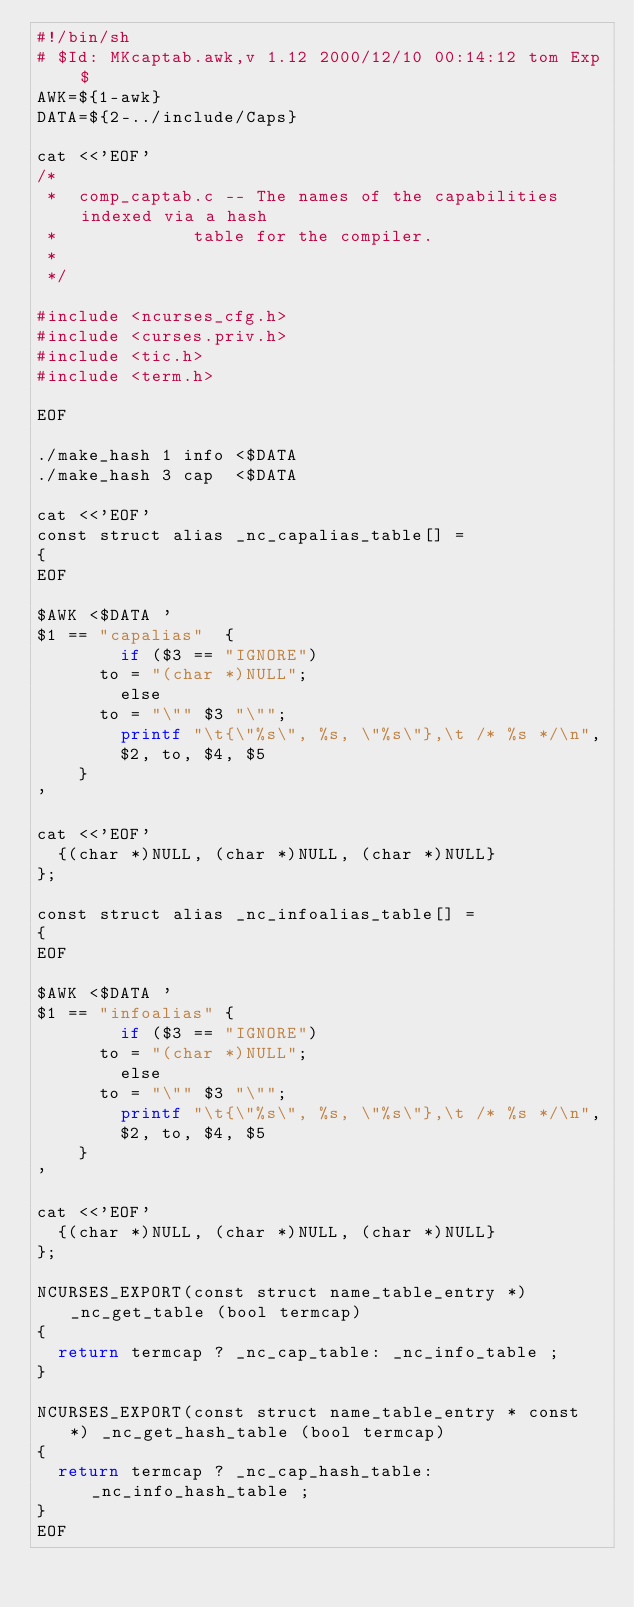<code> <loc_0><loc_0><loc_500><loc_500><_Awk_>#!/bin/sh
# $Id: MKcaptab.awk,v 1.12 2000/12/10 00:14:12 tom Exp $
AWK=${1-awk}
DATA=${2-../include/Caps}

cat <<'EOF'
/*
 *	comp_captab.c -- The names of the capabilities indexed via a hash
 *		         table for the compiler.
 *
 */

#include <ncurses_cfg.h>
#include <curses.priv.h>
#include <tic.h>
#include <term.h>

EOF

./make_hash 1 info <$DATA
./make_hash 3 cap  <$DATA

cat <<'EOF'
const struct alias _nc_capalias_table[] =
{
EOF

$AWK <$DATA '
$1 == "capalias"	{
		    if ($3 == "IGNORE")
			to = "(char *)NULL";
		    else
			to = "\"" $3 "\"";
		    printf "\t{\"%s\", %s, \"%s\"},\t /* %s */\n",
				$2, to, $4, $5
		}
'

cat <<'EOF'
	{(char *)NULL, (char *)NULL, (char *)NULL}
};

const struct alias _nc_infoalias_table[] =
{
EOF

$AWK <$DATA '
$1 == "infoalias"	{
		    if ($3 == "IGNORE")
			to = "(char *)NULL";
		    else
			to = "\"" $3 "\"";
		    printf "\t{\"%s\", %s, \"%s\"},\t /* %s */\n",
				$2, to, $4, $5
		}
'

cat <<'EOF'
	{(char *)NULL, (char *)NULL, (char *)NULL}
};

NCURSES_EXPORT(const struct name_table_entry *) _nc_get_table (bool termcap)
{
	return termcap ? _nc_cap_table: _nc_info_table ;
}

NCURSES_EXPORT(const struct name_table_entry * const *) _nc_get_hash_table (bool termcap)
{
	return termcap ? _nc_cap_hash_table: _nc_info_hash_table ;
}
EOF
</code> 